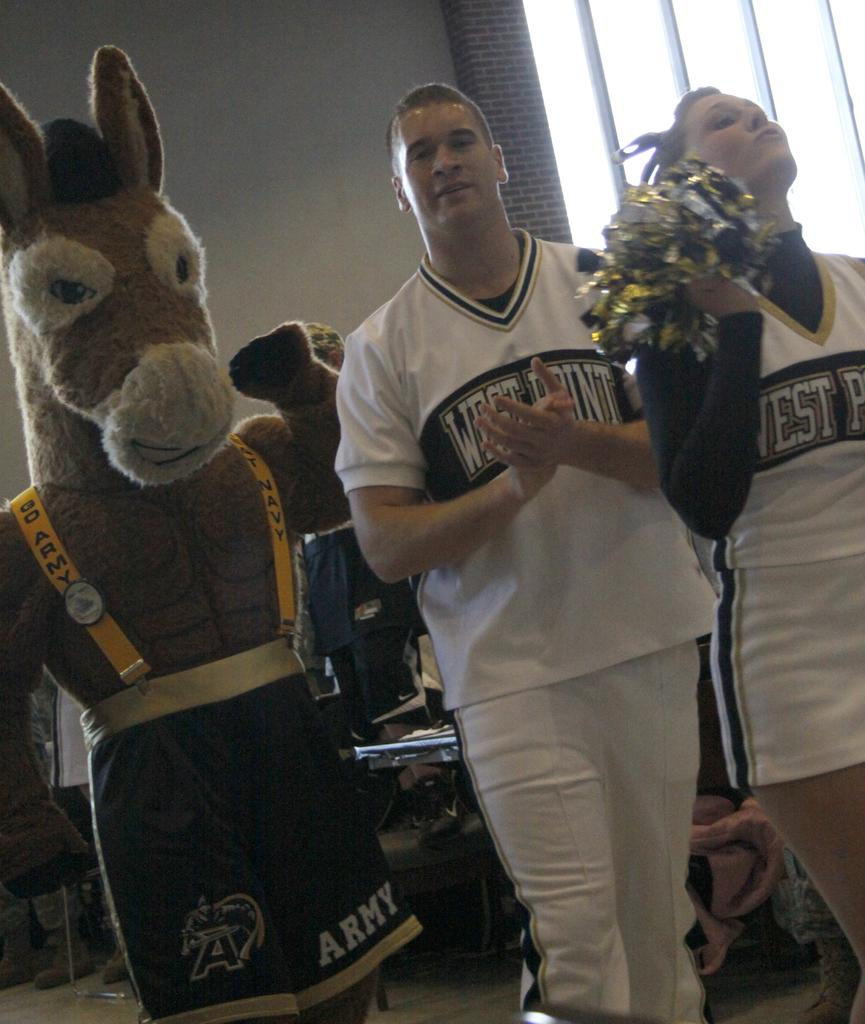<image>
Summarize the visual content of the image. A man and woman in West Point shirts next to a donkey mascot. 